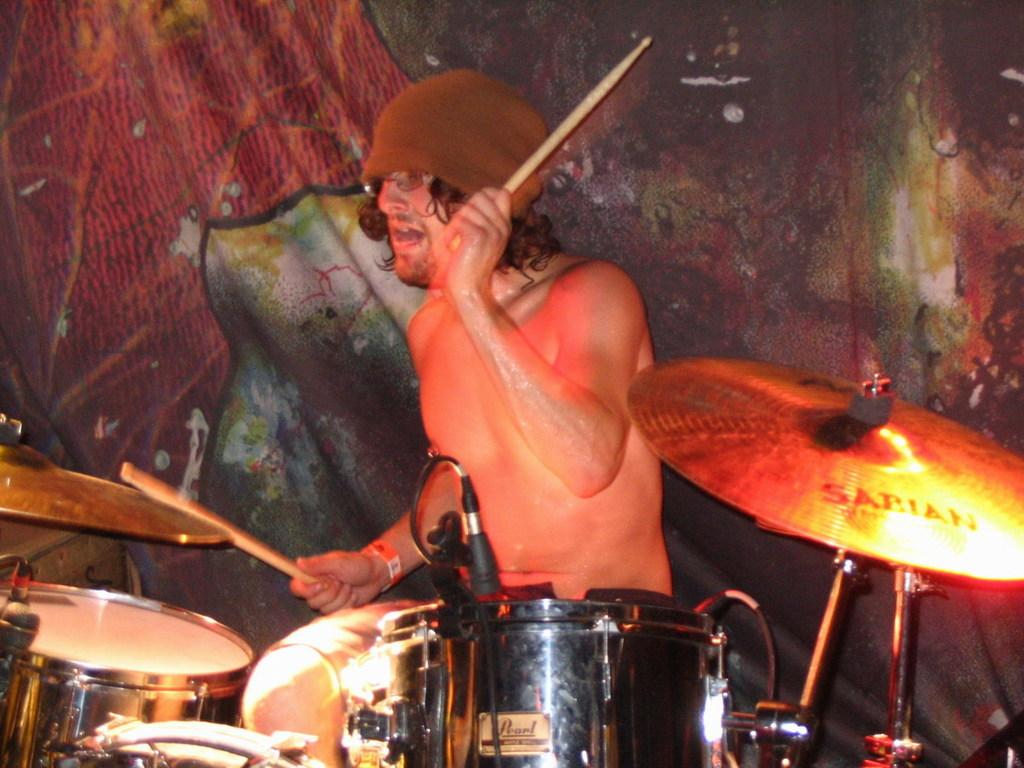What is the man in the image doing? The man is playing drums. What can be seen behind the man in the image? There is a designed wall in the background of the image. What type of grain is being used to flavor the man's drumsticks, can be seen in the image? There is no poison or grain present in the image. 